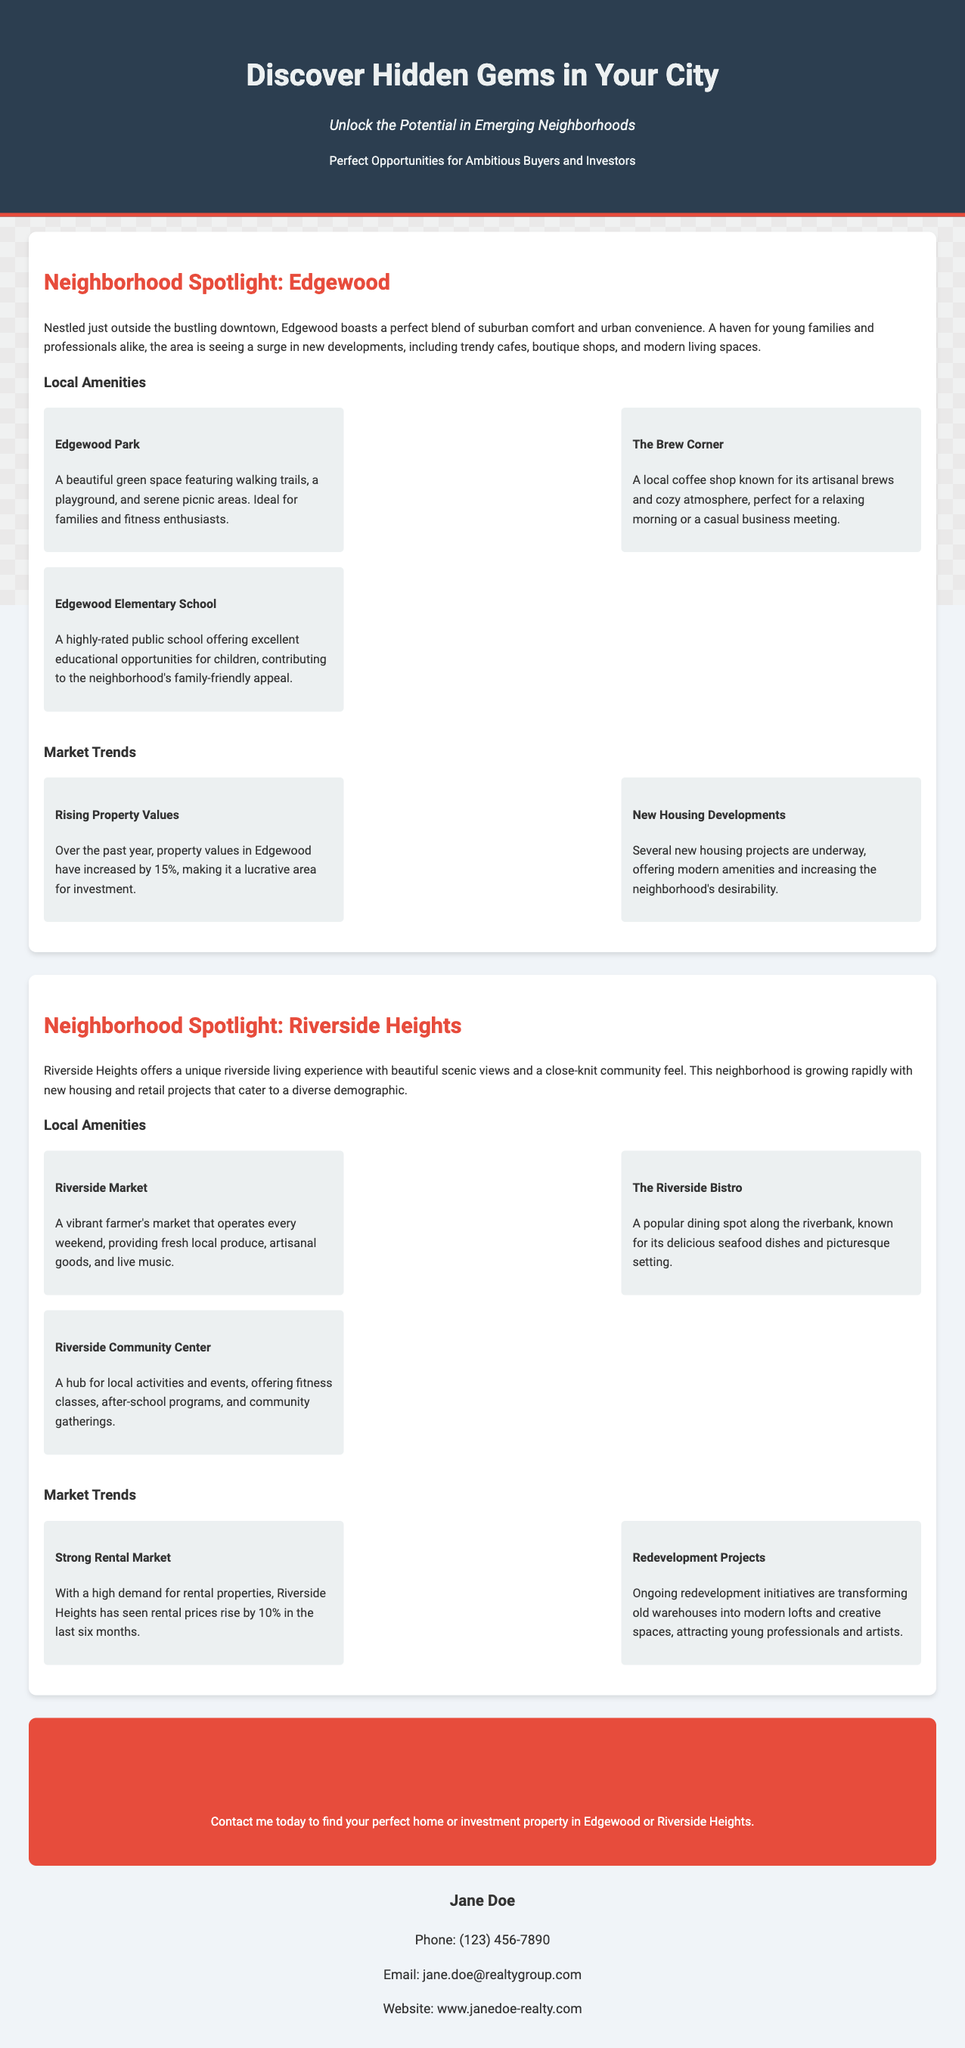What is the name of the first neighborhood spotlighted? The document specifically mentions "Edgewood" as the first neighborhood highlighted in the spotlight.
Answer: Edgewood What is the increase in property values in Edgewood over the past year? The document states that property values in Edgewood have increased by 15%, indicating a significant positive trend in the real estate market there.
Answer: 15% What amenities are available in Riverside Heights? Three amenities listed in Riverside Heights include Riverside Market, The Riverside Bistro, and Riverside Community Center, as indicated in the document.
Answer: Riverside Market, The Riverside Bistro, Riverside Community Center Which neighborhood offers a strong rental market with rising prices? The document highlights Riverside Heights as having a strong rental market with a reported increase in rental prices.
Answer: Riverside Heights What type of events does the Riverside Community Center host? The document mentions that the Riverside Community Center serves as a hub for local activities and events, providing various community gatherings.
Answer: Community gatherings What is the contact email for the real estate agent? The document lists the contact email address for Jane Doe, the agent, as part of her contact information.
Answer: jane.doe@realtygroup.com What is one reason that makes Edgewood appealing for families? Edgewood is described as having a highly-rated public school that contributes to its family-friendly appeal, providing a solid education for children.
Answer: Edgewood Elementary School What is the primary theme of the advertisement? The advertisement focuses on discovering emerging neighborhoods that offer great opportunities for buyers and investors, emphasizing up-and-coming areas and community insights.
Answer: Discover Hidden Gems in Your City 